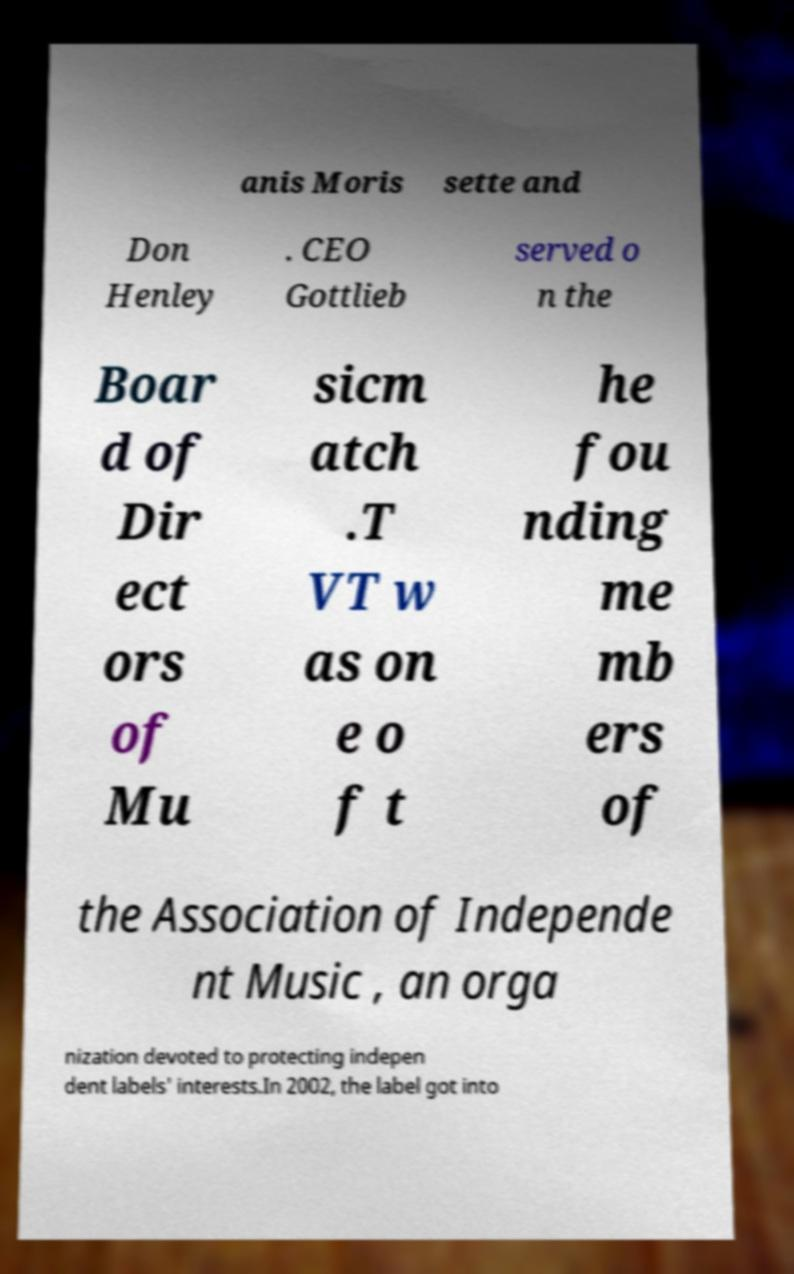Can you read and provide the text displayed in the image?This photo seems to have some interesting text. Can you extract and type it out for me? anis Moris sette and Don Henley . CEO Gottlieb served o n the Boar d of Dir ect ors of Mu sicm atch .T VT w as on e o f t he fou nding me mb ers of the Association of Independe nt Music , an orga nization devoted to protecting indepen dent labels' interests.In 2002, the label got into 